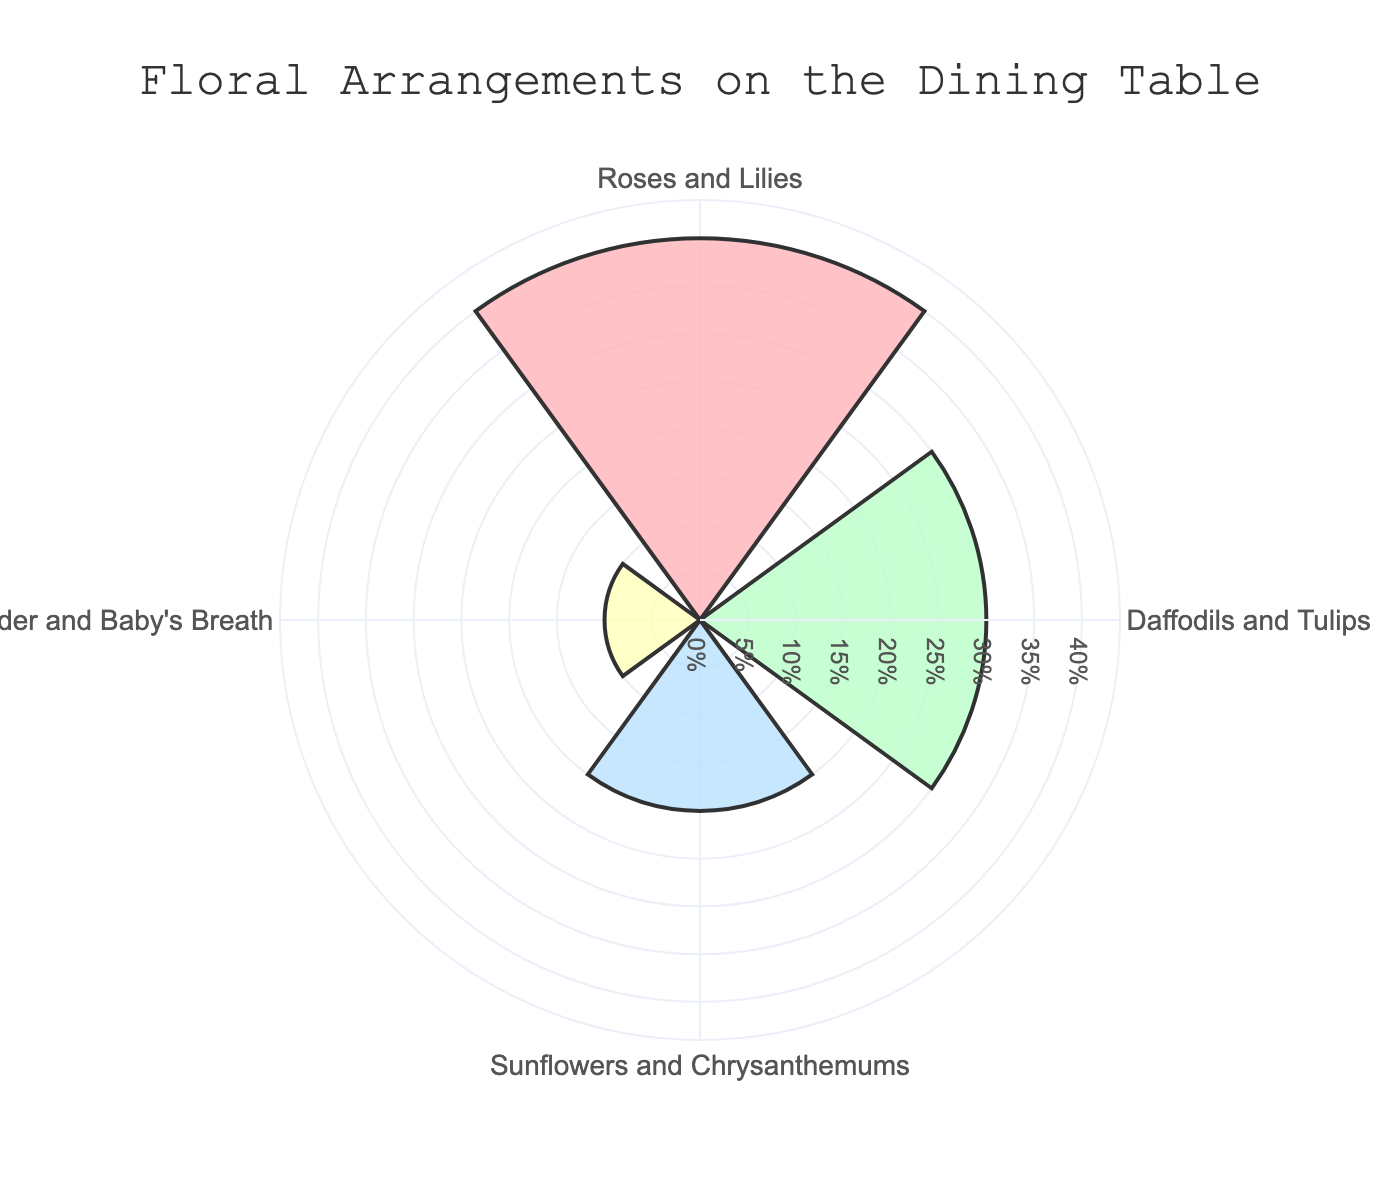what is the title of the chart? The title is usually located at the top of the chart and summarises the content of the figure. Here, the title is "Floral Arrangements on the Dining Table", as shown at the top of the figure.
Answer: Floral Arrangements on the Dining Table How many different floral arrangements are depicted in the chart? Each segment represents a different floral arrangement. By counting them, we see four segments: "Roses and Lilies", "Daffodils and Tulips", "Sunflowers and Chrysanthemums", and "Lavender and Baby's Breath".
Answer: Four Which floral arrangement has the highest proportion? Look for the arrangement with the largest bar extending outward from the center of the rose chart. "Roses and Lilies" has the longest bar, indicating the highest proportion of 40%.
Answer: Roses and Lilies What is the combined proportion of "Daffodils and Tulips" and "Sunflowers and Chrysanthemums"? Add the proportions of the two arrangements mentioned: "Daffodils and Tulips" is 30% and "Sunflowers and Chrysanthemums" is 20%. Thus, 30% + 20% = 50%.
Answer: 50% Which floral arrangement has the smallest proportion? The smallest bar extending from the center of the rose chart represents the smallest proportion. "Lavender and Baby's Breath" has the smallest bar, indicating the smallest proportion of 10%.
Answer: Lavender and Baby's Breath What is the difference in proportion between the largest and smallest arrangement? Find the proportions for "Roses and Lilies" (largest) and "Lavender and Baby's Breath" (smallest). The difference is 40% - 10% = 30%.
Answer: 30% What proportion of the floral arrangements on the dining table consist of more than one flower type? All the arrangements listed are combinations of different flowers: "Roses and Lilies", "Daffodils and Tulips", "Sunflowers and Chrysanthemums", "Lavender and Baby's Breath".
Answer: 100% Rank the floral arrangements from highest to lowest in proportion. Arrange the floral arrangements in descending order of their proportions: "Roses and Lilies" (40%), "Daffodils and Tulips" (30%), "Sunflowers and Chrysanthemums" (20%), "Lavender and Baby's Breath" (10%).
Answer: Roses and Lilies > Daffodils and Tulips > Sunflowers and Chrysanthemums > Lavender and Baby's Breath 